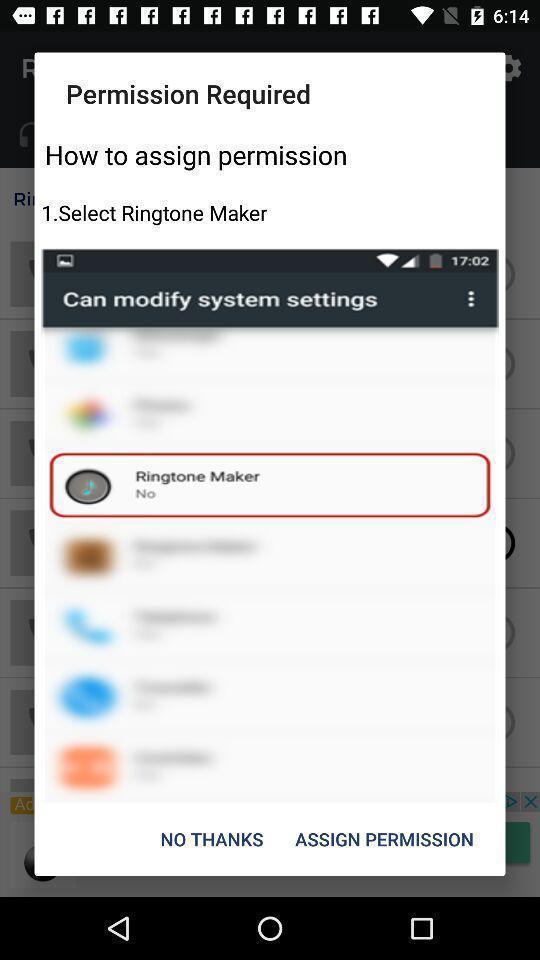What details can you identify in this image? Pop-up asking authentication to accept the highlighted app. 